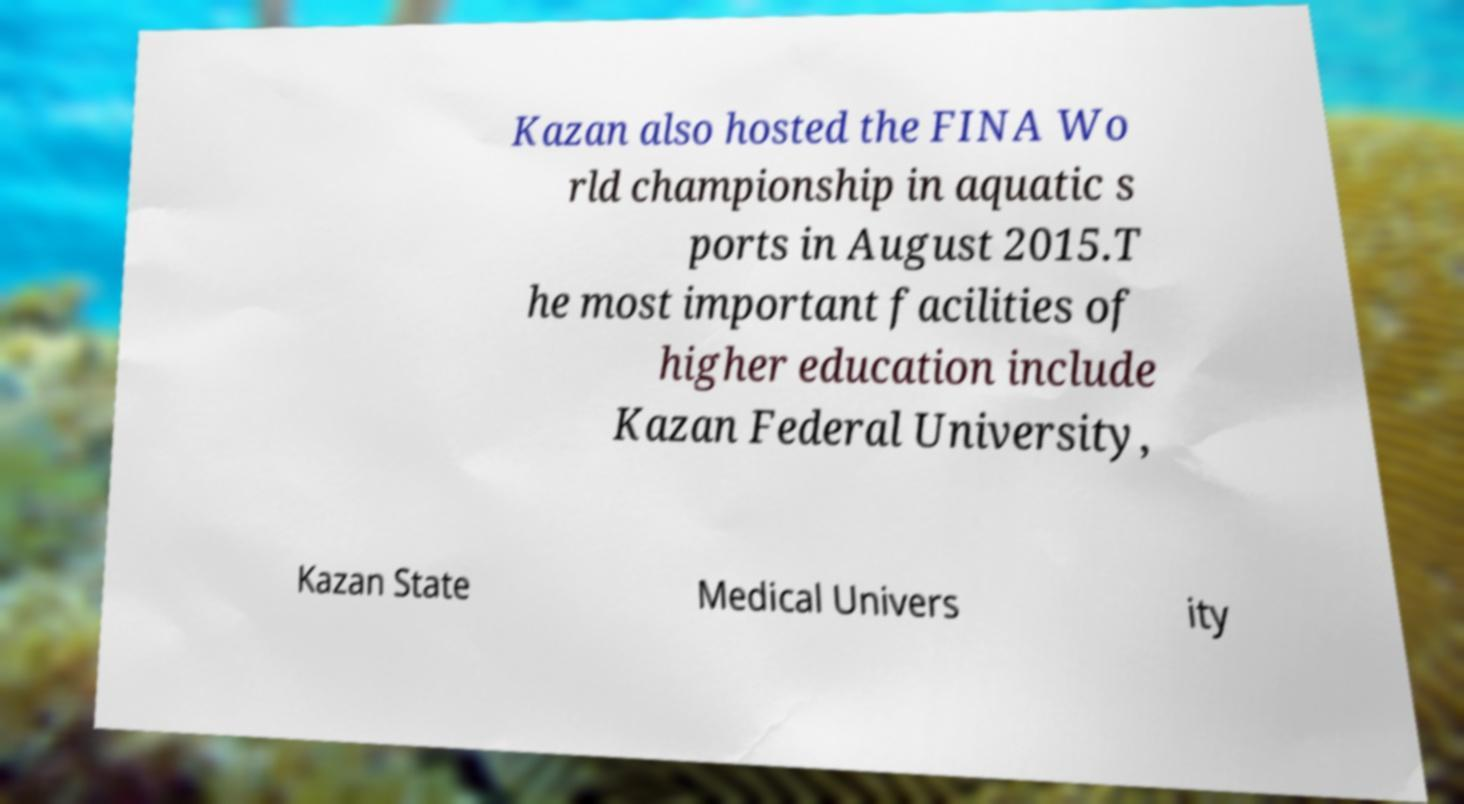Can you read and provide the text displayed in the image?This photo seems to have some interesting text. Can you extract and type it out for me? Kazan also hosted the FINA Wo rld championship in aquatic s ports in August 2015.T he most important facilities of higher education include Kazan Federal University, Kazan State Medical Univers ity 